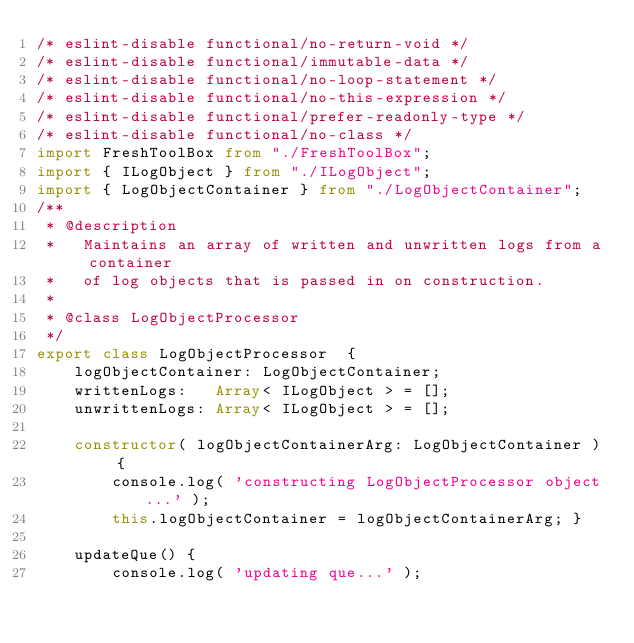Convert code to text. <code><loc_0><loc_0><loc_500><loc_500><_TypeScript_>/* eslint-disable functional/no-return-void */
/* eslint-disable functional/immutable-data */
/* eslint-disable functional/no-loop-statement */
/* eslint-disable functional/no-this-expression */
/* eslint-disable functional/prefer-readonly-type */
/* eslint-disable functional/no-class */
import FreshToolBox from "./FreshToolBox";
import { ILogObject } from "./ILogObject";
import { LogObjectContainer } from "./LogObjectContainer";
/**
 * @description
 *   Maintains an array of written and unwritten logs from a container
 *   of log objects that is passed in on construction.
 *
 * @class LogObjectProcessor
 */
export class LogObjectProcessor  {
    logObjectContainer: LogObjectContainer;
    writtenLogs:   Array< ILogObject > = [];
    unwrittenLogs: Array< ILogObject > = [];

    constructor( logObjectContainerArg: LogObjectContainer ) {
        console.log( 'constructing LogObjectProcessor object...' );
        this.logObjectContainer = logObjectContainerArg; }

    updateQue() {
        console.log( 'updating que...' );</code> 